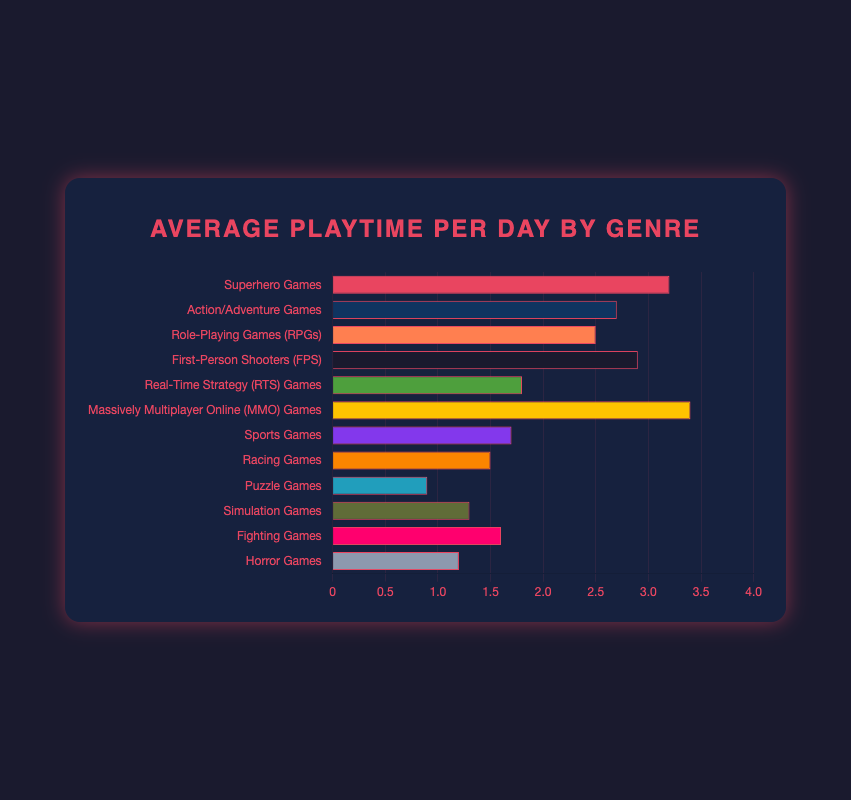Which genre has the highest average playtime per day? The highest bar corresponds to "Massively Multiplayer Online (MMO) Games" with a playtime of 3.4 hours per day.
Answer: Massively Multiplayer Online (MMO) Games Which genres have a lower average playtime per day than Action/Adventure Games? "Action/Adventure Games" has an average playtime of 2.7 hours. The bars shorter than this one are for genres: "Role-Playing Games (RPGs)", "Real-Time Strategy (RTS) Games", "Sports Games", "Racing Games", "Puzzle Games", "Simulation Games", "Fighting Games", and "Horror Games".
Answer: Eight genres How much more playtime do Superhero Games have compared to Puzzle Games? Playtime for "Superhero Games" is 3.2 hours and for "Puzzle Games" it's 0.9 hours. The difference is 3.2 - 0.9 = 2.3 hours.
Answer: 2.3 hours What is the combined average playtime of Real-Time Strategy (RTS) Games and Racing Games? Playtime for "Real-Time Strategy (RTS) Games" is 1.8 hours and for "Racing Games" is 1.5 hours. The sum is 1.8 + 1.5 = 3.3 hours.
Answer: 3.3 hours Are there more genres with average playtime above 2 hours or below 2 hours? Genres above 2 hours: "Superhero Games", "Action/Adventure Games", "Role-Playing Games (RPGs)", "First-Person Shooters (FPS)", "Massively Multiplayer Online (MMO) Games". Genres below 2 hours: "Real-Time Strategy (RTS) Games", "Sports Games", "Racing Games", "Puzzle Games", "Simulation Games", "Fighting Games", "Horror Games". There are 5 genres above 2 hours and 7 genres below 2 hours.
Answer: Below 2 hours What's the median average playtime among all listed genres? Listed playtimes are: 0.9, 1.2, 1.3, 1.5, 1.6, 1.7, 1.8, 2.5, 2.7, 2.9, 3.2, 3.4. The median is the average of the 6th and 7th values, which are 1.7 and 1.8. Median is (1.7 + 1.8) / 2 = 1.75 hours.
Answer: 1.75 hours Which genre has the darkest bar in the chart? The bar with the darkest color corresponds to "Puzzle Games".
Answer: Puzzle Games How much total average playtime do Horror Games, Fighting Games, and Simulation Games accumulate? Playtimes: Horror Games = 1.2 hours, Fighting Games = 1.6 hours, Simulation Games = 1.3 hours. The total is 1.2 + 1.6 + 1.3 = 4.1 hours.
Answer: 4.1 hours 